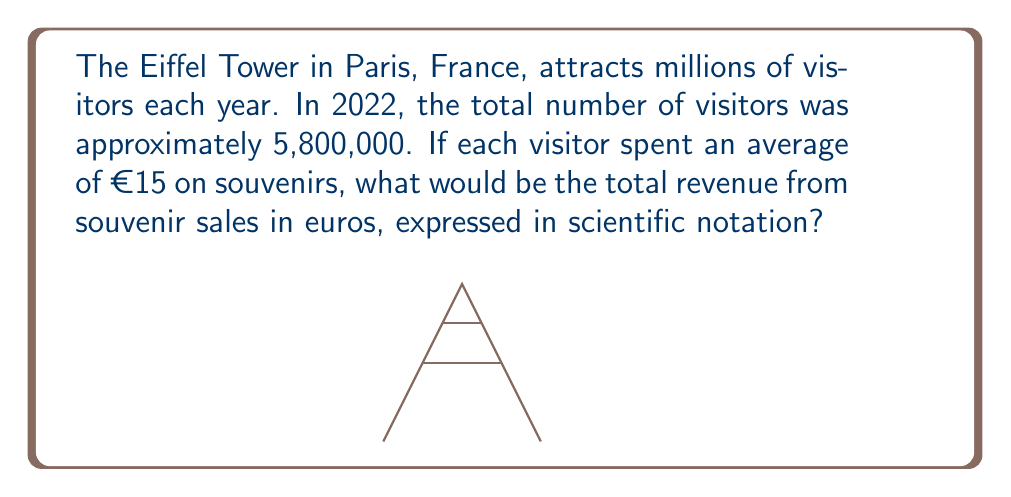Help me with this question. Let's solve this step-by-step:

1) First, we need to calculate the total revenue:
   $5,800,000 \times €15 = €87,000,000$

2) To convert this to scientific notation, we need to express it as a number between 1 and 10 multiplied by a power of 10.

3) We can write €87,000,000 as:
   $€87,000,000 = €8.7 \times 10,000,000 = €8.7 \times 10^7$

4) In scientific notation, we always use the format $a \times 10^n$ where $1 \leq a < 10$ and $n$ is an integer.

5) Our result, $€8.7 \times 10^7$, is already in this format.

Therefore, the total revenue from souvenir sales, expressed in scientific notation, is $€8.7 \times 10^7$.
Answer: $€8.7 \times 10^7$ 